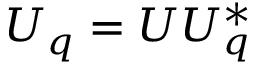Convert formula to latex. <formula><loc_0><loc_0><loc_500><loc_500>U _ { q } = U U _ { q } ^ { * }</formula> 